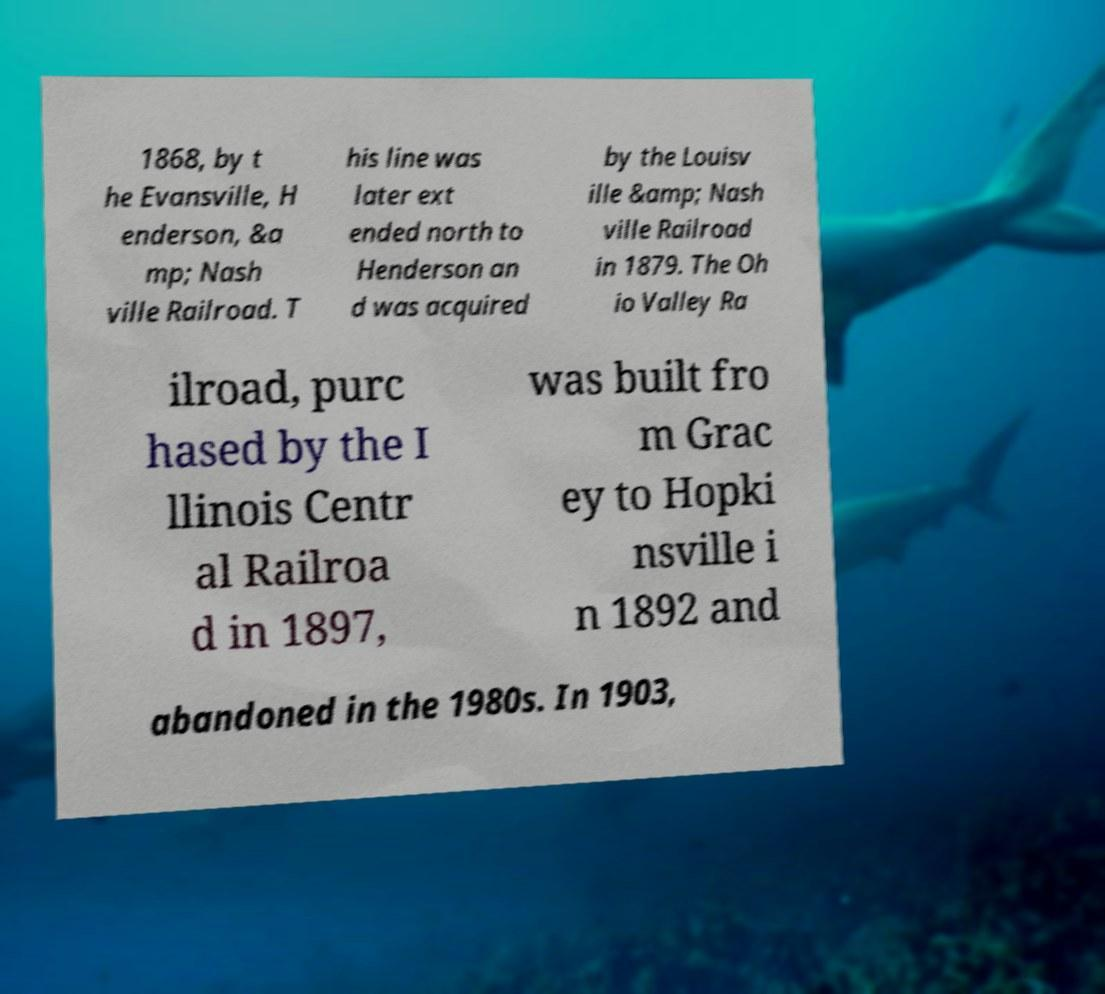Could you extract and type out the text from this image? 1868, by t he Evansville, H enderson, &a mp; Nash ville Railroad. T his line was later ext ended north to Henderson an d was acquired by the Louisv ille &amp; Nash ville Railroad in 1879. The Oh io Valley Ra ilroad, purc hased by the I llinois Centr al Railroa d in 1897, was built fro m Grac ey to Hopki nsville i n 1892 and abandoned in the 1980s. In 1903, 